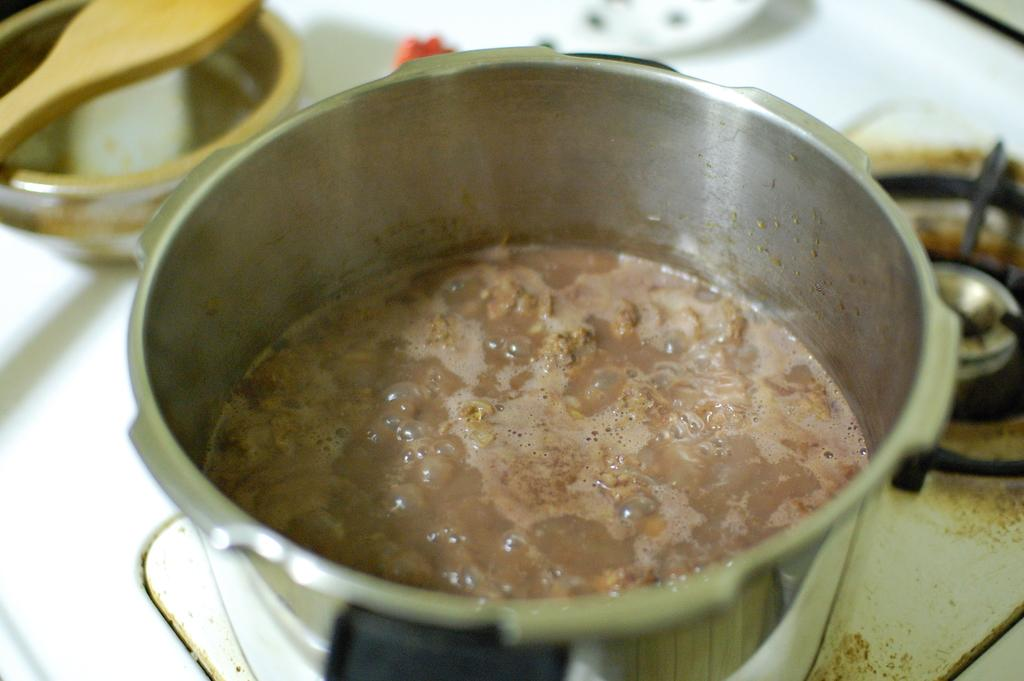What cooking appliance is visible in the image? There is a pressure cooker in the image. What is inside the pressure cooker? The pressure cooker contains a food item. Where is the pressure cooker located in the image? The pressure cooker is placed on a stove. What other kitchen item can be seen in the image? There is a bowl in the image. What utensil is present in the image? There is a wooden serving spoon in the image. What type of hook is used to hang the beef in the image? There is no beef or hook present in the image. 